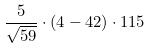<formula> <loc_0><loc_0><loc_500><loc_500>\frac { 5 } { \sqrt { 5 9 } } \cdot ( 4 - 4 2 ) \cdot 1 1 5</formula> 